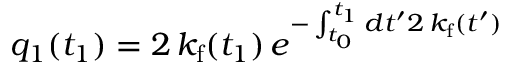<formula> <loc_0><loc_0><loc_500><loc_500>q _ { 1 } ( t _ { 1 } ) = 2 \, k _ { f } ( t _ { 1 } ) \, e ^ { - \int _ { t _ { 0 } } ^ { t _ { 1 } } d t ^ { \prime } 2 \, k _ { f } ( t ^ { \prime } ) }</formula> 